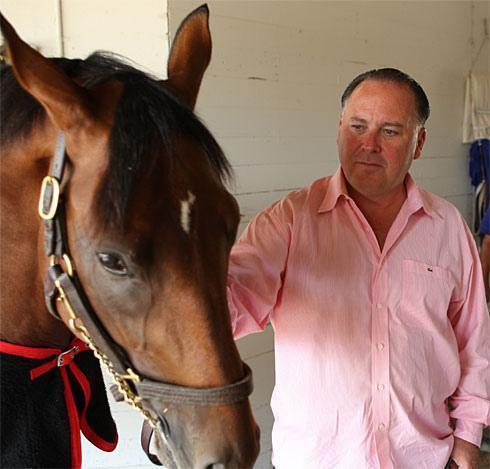How many people's faces do you see?
Give a very brief answer. 1. How many baby giraffes are there?
Give a very brief answer. 0. 